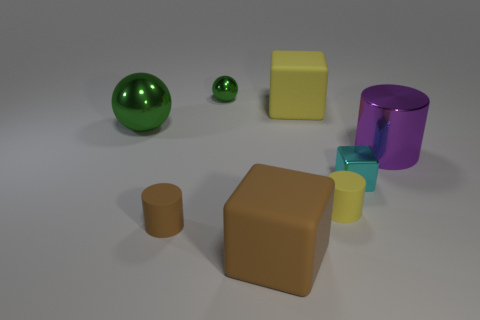There is a object that is the same color as the large sphere; what shape is it?
Offer a terse response. Sphere. Are there any other things of the same color as the shiny cylinder?
Your response must be concise. No. There is a cube that is in front of the large green ball and behind the brown block; what is its size?
Offer a very short reply. Small. Is the large brown thing the same shape as the cyan metal thing?
Provide a short and direct response. Yes. There is a big metal thing that is on the right side of the small metal cube; how many objects are behind it?
Ensure brevity in your answer.  3. There is a big thing that is made of the same material as the yellow cube; what is its shape?
Make the answer very short. Cube. How many blue things are either small objects or spheres?
Keep it short and to the point. 0. There is a large block that is behind the big metal object on the right side of the small brown cylinder; is there a big purple cylinder to the right of it?
Offer a very short reply. Yes. Is the number of large cubes less than the number of tiny red metallic cylinders?
Your response must be concise. No. Is the shape of the large metallic object on the right side of the big brown block the same as  the tiny yellow matte object?
Provide a short and direct response. Yes. 